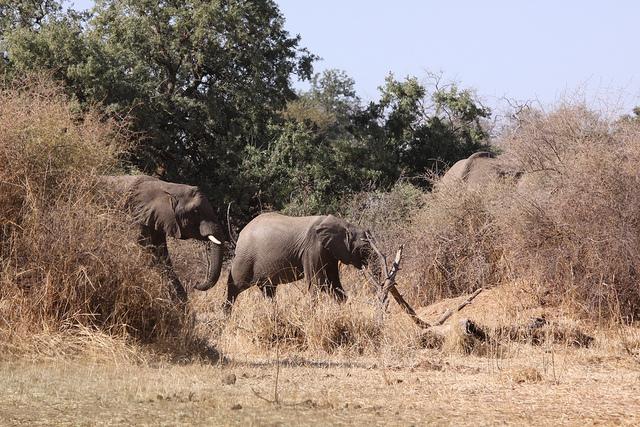Are there clouds in the sky?
Give a very brief answer. No. How many elephants are in this photo?
Quick response, please. 2. Are these elephants at the zoo?
Quick response, please. No. How many elephants are there?
Be succinct. 2. Is this a confrontation?
Quick response, please. No. Are the elephants fully grown?
Write a very short answer. No. 